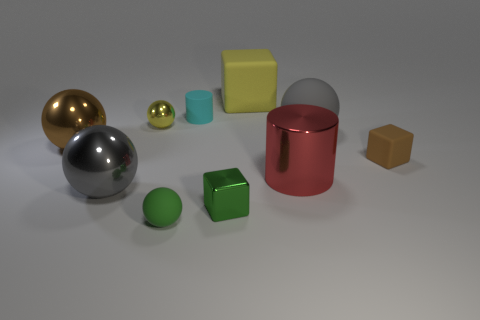Do the small metal sphere and the matte block that is behind the yellow metallic sphere have the same color?
Your answer should be compact. Yes. What is the material of the small cube that is on the right side of the gray matte thing?
Keep it short and to the point. Rubber. Are there any balls that have the same color as the metallic cube?
Ensure brevity in your answer.  Yes. There is a metal cylinder that is the same size as the brown shiny object; what color is it?
Give a very brief answer. Red. How many large things are green matte objects or gray balls?
Provide a short and direct response. 2. Is the number of large brown spheres that are right of the big red shiny cylinder the same as the number of spheres that are behind the small green cube?
Your response must be concise. No. What number of metallic spheres are the same size as the yellow block?
Offer a very short reply. 2. How many purple things are either large cubes or rubber cubes?
Offer a very short reply. 0. Is the number of matte cylinders that are left of the tiny yellow shiny sphere the same as the number of red spheres?
Give a very brief answer. Yes. There is a yellow object that is to the right of the small green ball; what size is it?
Make the answer very short. Large. 